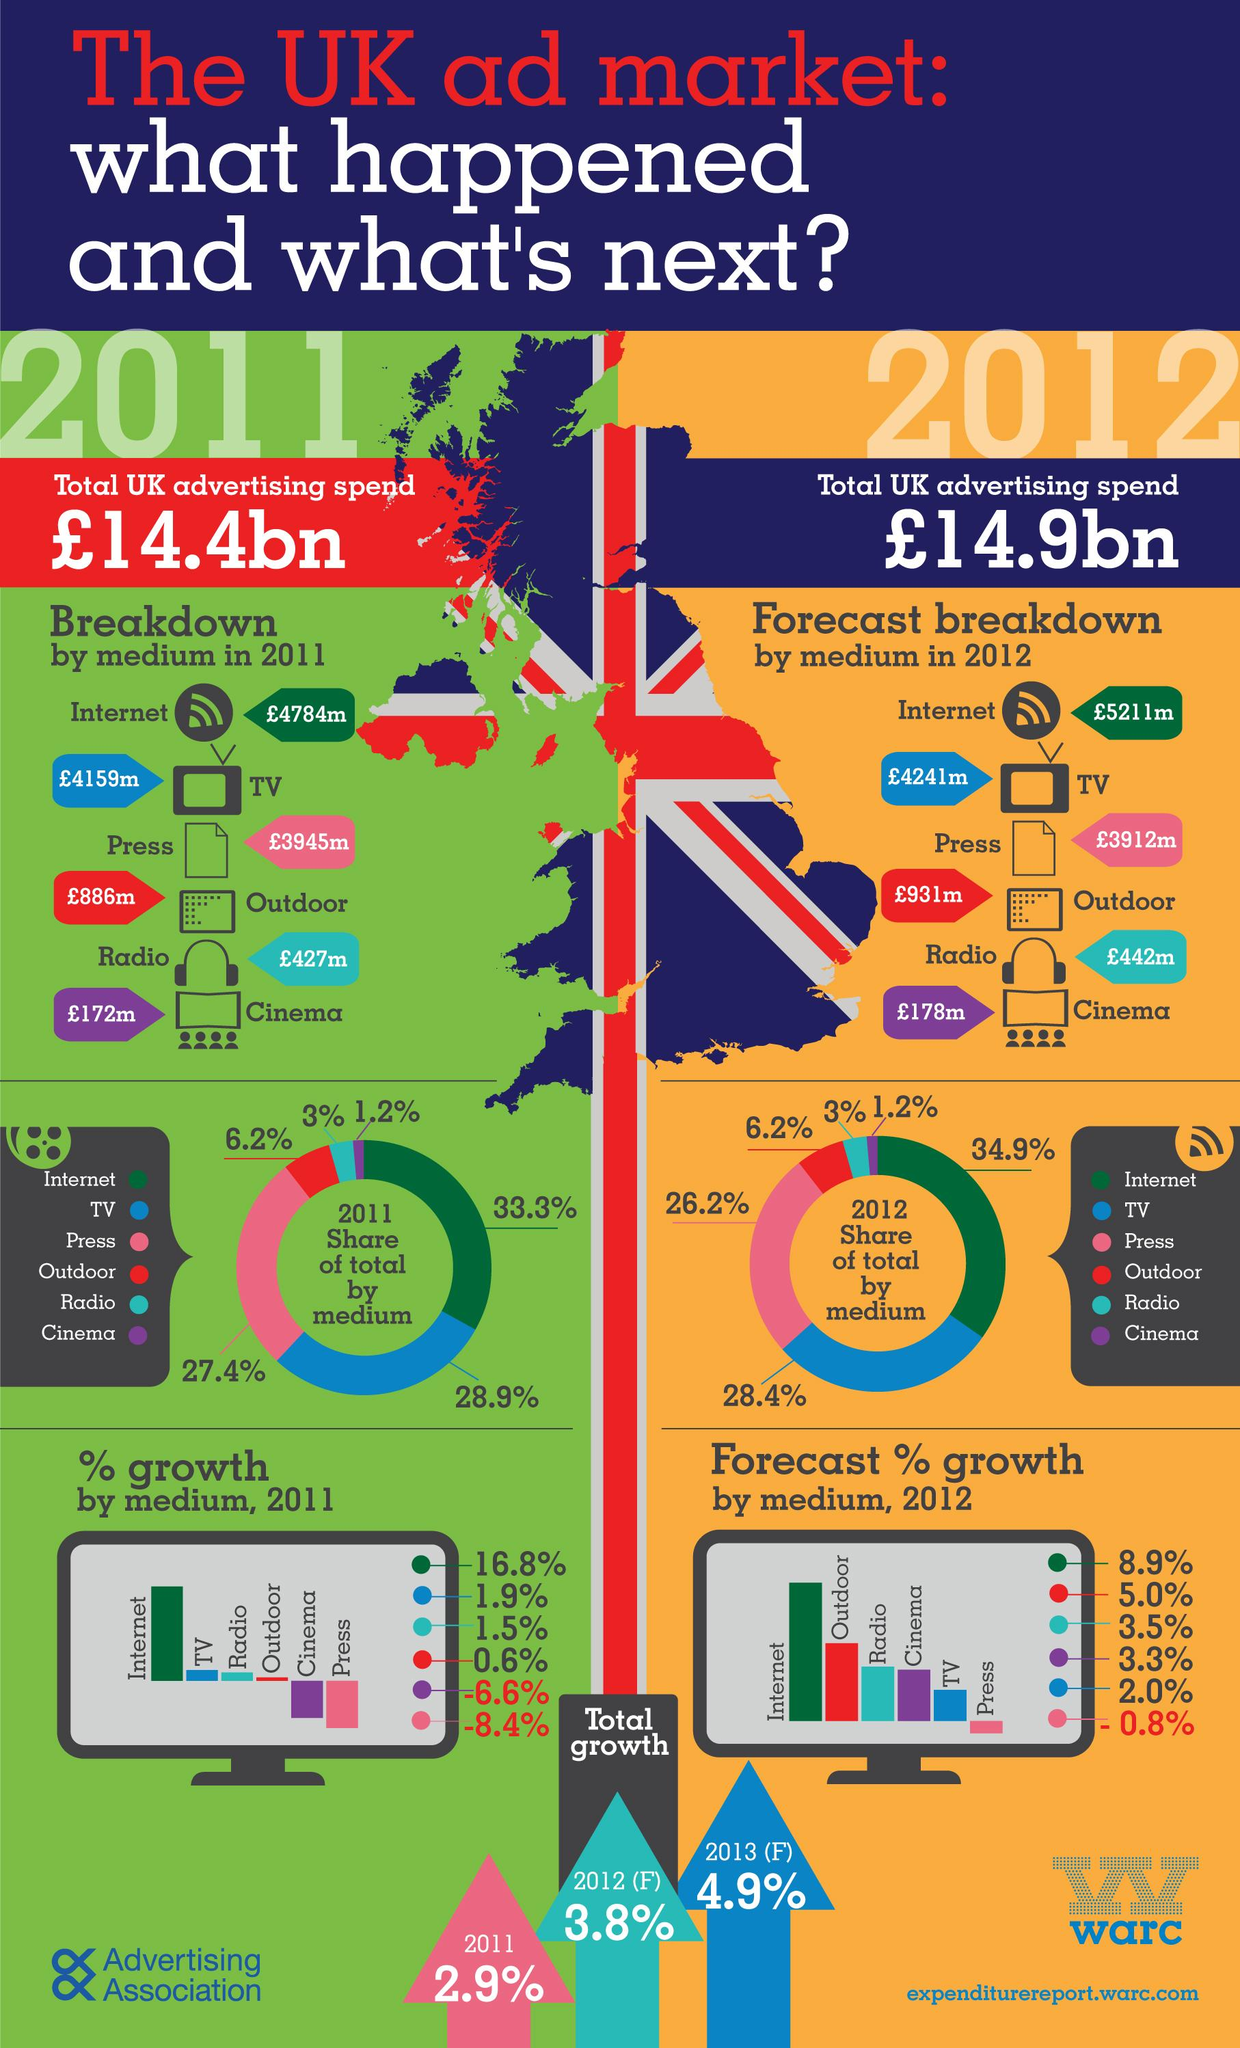Mention a couple of crucial points in this snapshot. Outdoor, radio, and cinema are the three mediums that have the same share percentage in both 2011 and 2012. The total growth expected in 2013 is expected to be approximately 4.9%. In 2011, the share of advertisements through television was greater than that of advertisements through the press by 1.5%. In 2012, the total amount of advertising expenditure was higher than in previous years. Five mediums were used for advertising. 